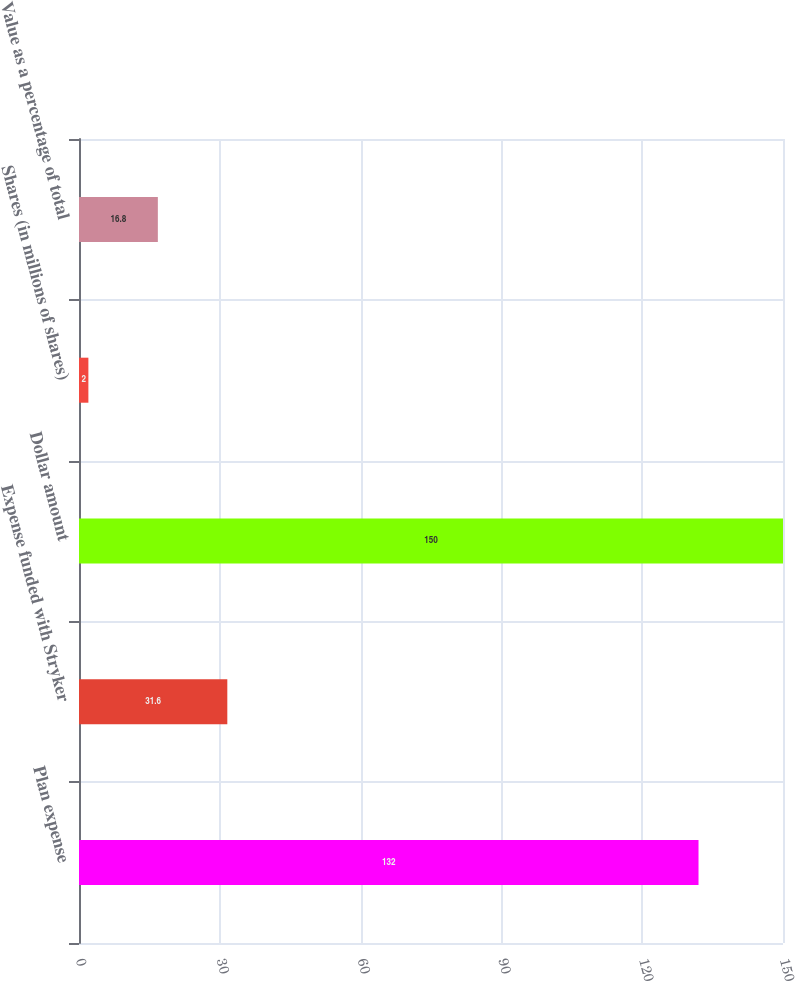<chart> <loc_0><loc_0><loc_500><loc_500><bar_chart><fcel>Plan expense<fcel>Expense funded with Stryker<fcel>Dollar amount<fcel>Shares (in millions of shares)<fcel>Value as a percentage of total<nl><fcel>132<fcel>31.6<fcel>150<fcel>2<fcel>16.8<nl></chart> 